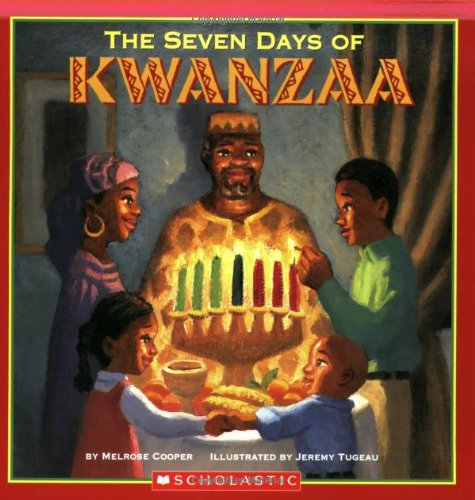What is the genre of this book? This book falls under the genre of Children's Books, aiming to educate young readers about cultural festivities and the importance of traditions like Kwanzaa. 